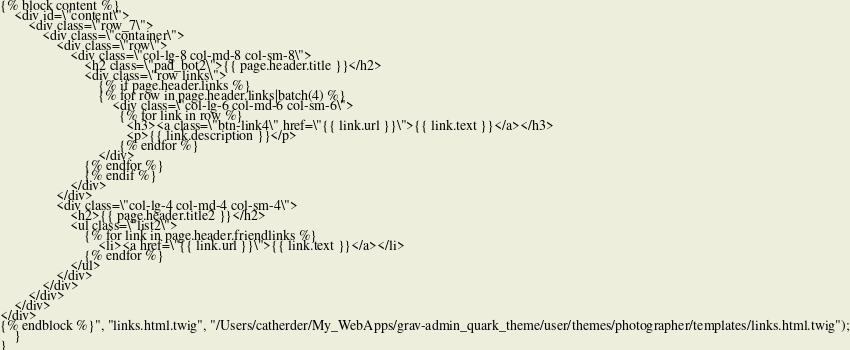<code> <loc_0><loc_0><loc_500><loc_500><_PHP_>{% block content %}
    <div id=\"content\">
        <div class=\"row_7\">
            <div class=\"container\">
                <div class=\"row\">
                    <div class=\"col-lg-8 col-md-8 col-sm-8\">
                        <h2 class=\"pad_bot2\">{{ page.header.title }}</h2>
                        <div class=\"row links\">
                            {% if page.header.links %}
                            {% for row in page.header.links|batch(4) %}
                                <div class=\"col-lg-6 col-md-6 col-sm-6\">
                                  {% for link in row %}
                                    <h3><a class=\"btn-link4\" href=\"{{ link.url }}\">{{ link.text }}</a></h3>
                                    <p>{{ link.description }}</p>
                                  {% endfor %}
                            </div>
                        {% endfor %}
                        {% endif %}
                    </div>
                </div>
                <div class=\"col-lg-4 col-md-4 col-sm-4\">
                    <h2>{{ page.header.title2 }}</h2>
                    <ul class=\"list2\">
                        {% for link in page.header.friendlinks %}
                            <li><a href=\"{{ link.url }}\">{{ link.text }}</a></li>
                        {% endfor %}
                    </ul> 
                </div>
            </div>
        </div>
    </div>
</div>
{% endblock %}", "links.html.twig", "/Users/catherder/My_WebApps/grav-admin_quark_theme/user/themes/photographer/templates/links.html.twig");
    }
}
</code> 